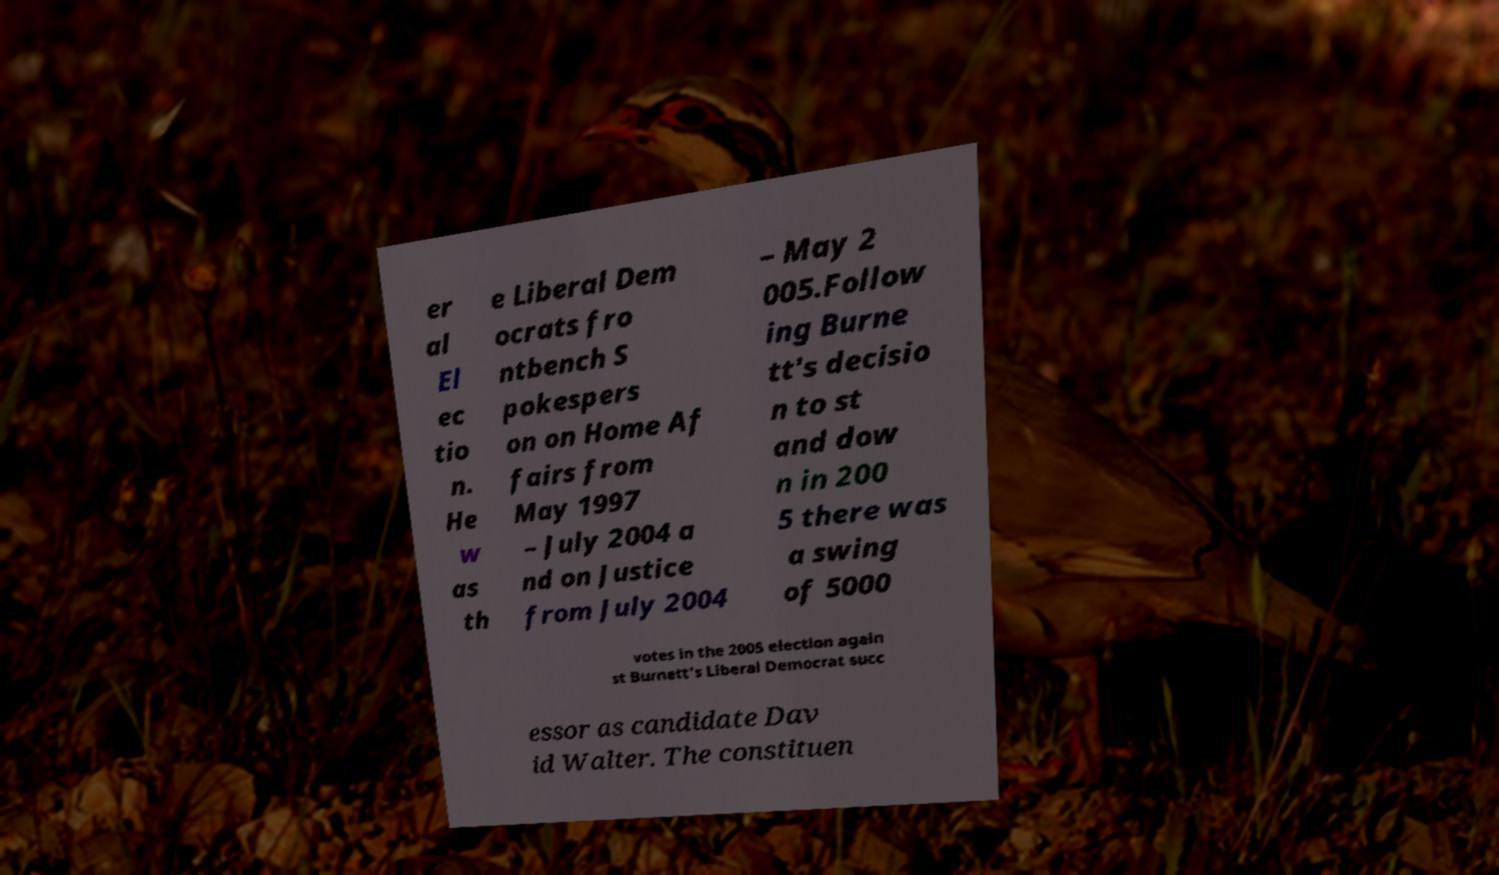I need the written content from this picture converted into text. Can you do that? er al El ec tio n. He w as th e Liberal Dem ocrats fro ntbench S pokespers on on Home Af fairs from May 1997 – July 2004 a nd on Justice from July 2004 – May 2 005.Follow ing Burne tt's decisio n to st and dow n in 200 5 there was a swing of 5000 votes in the 2005 election again st Burnett's Liberal Democrat succ essor as candidate Dav id Walter. The constituen 